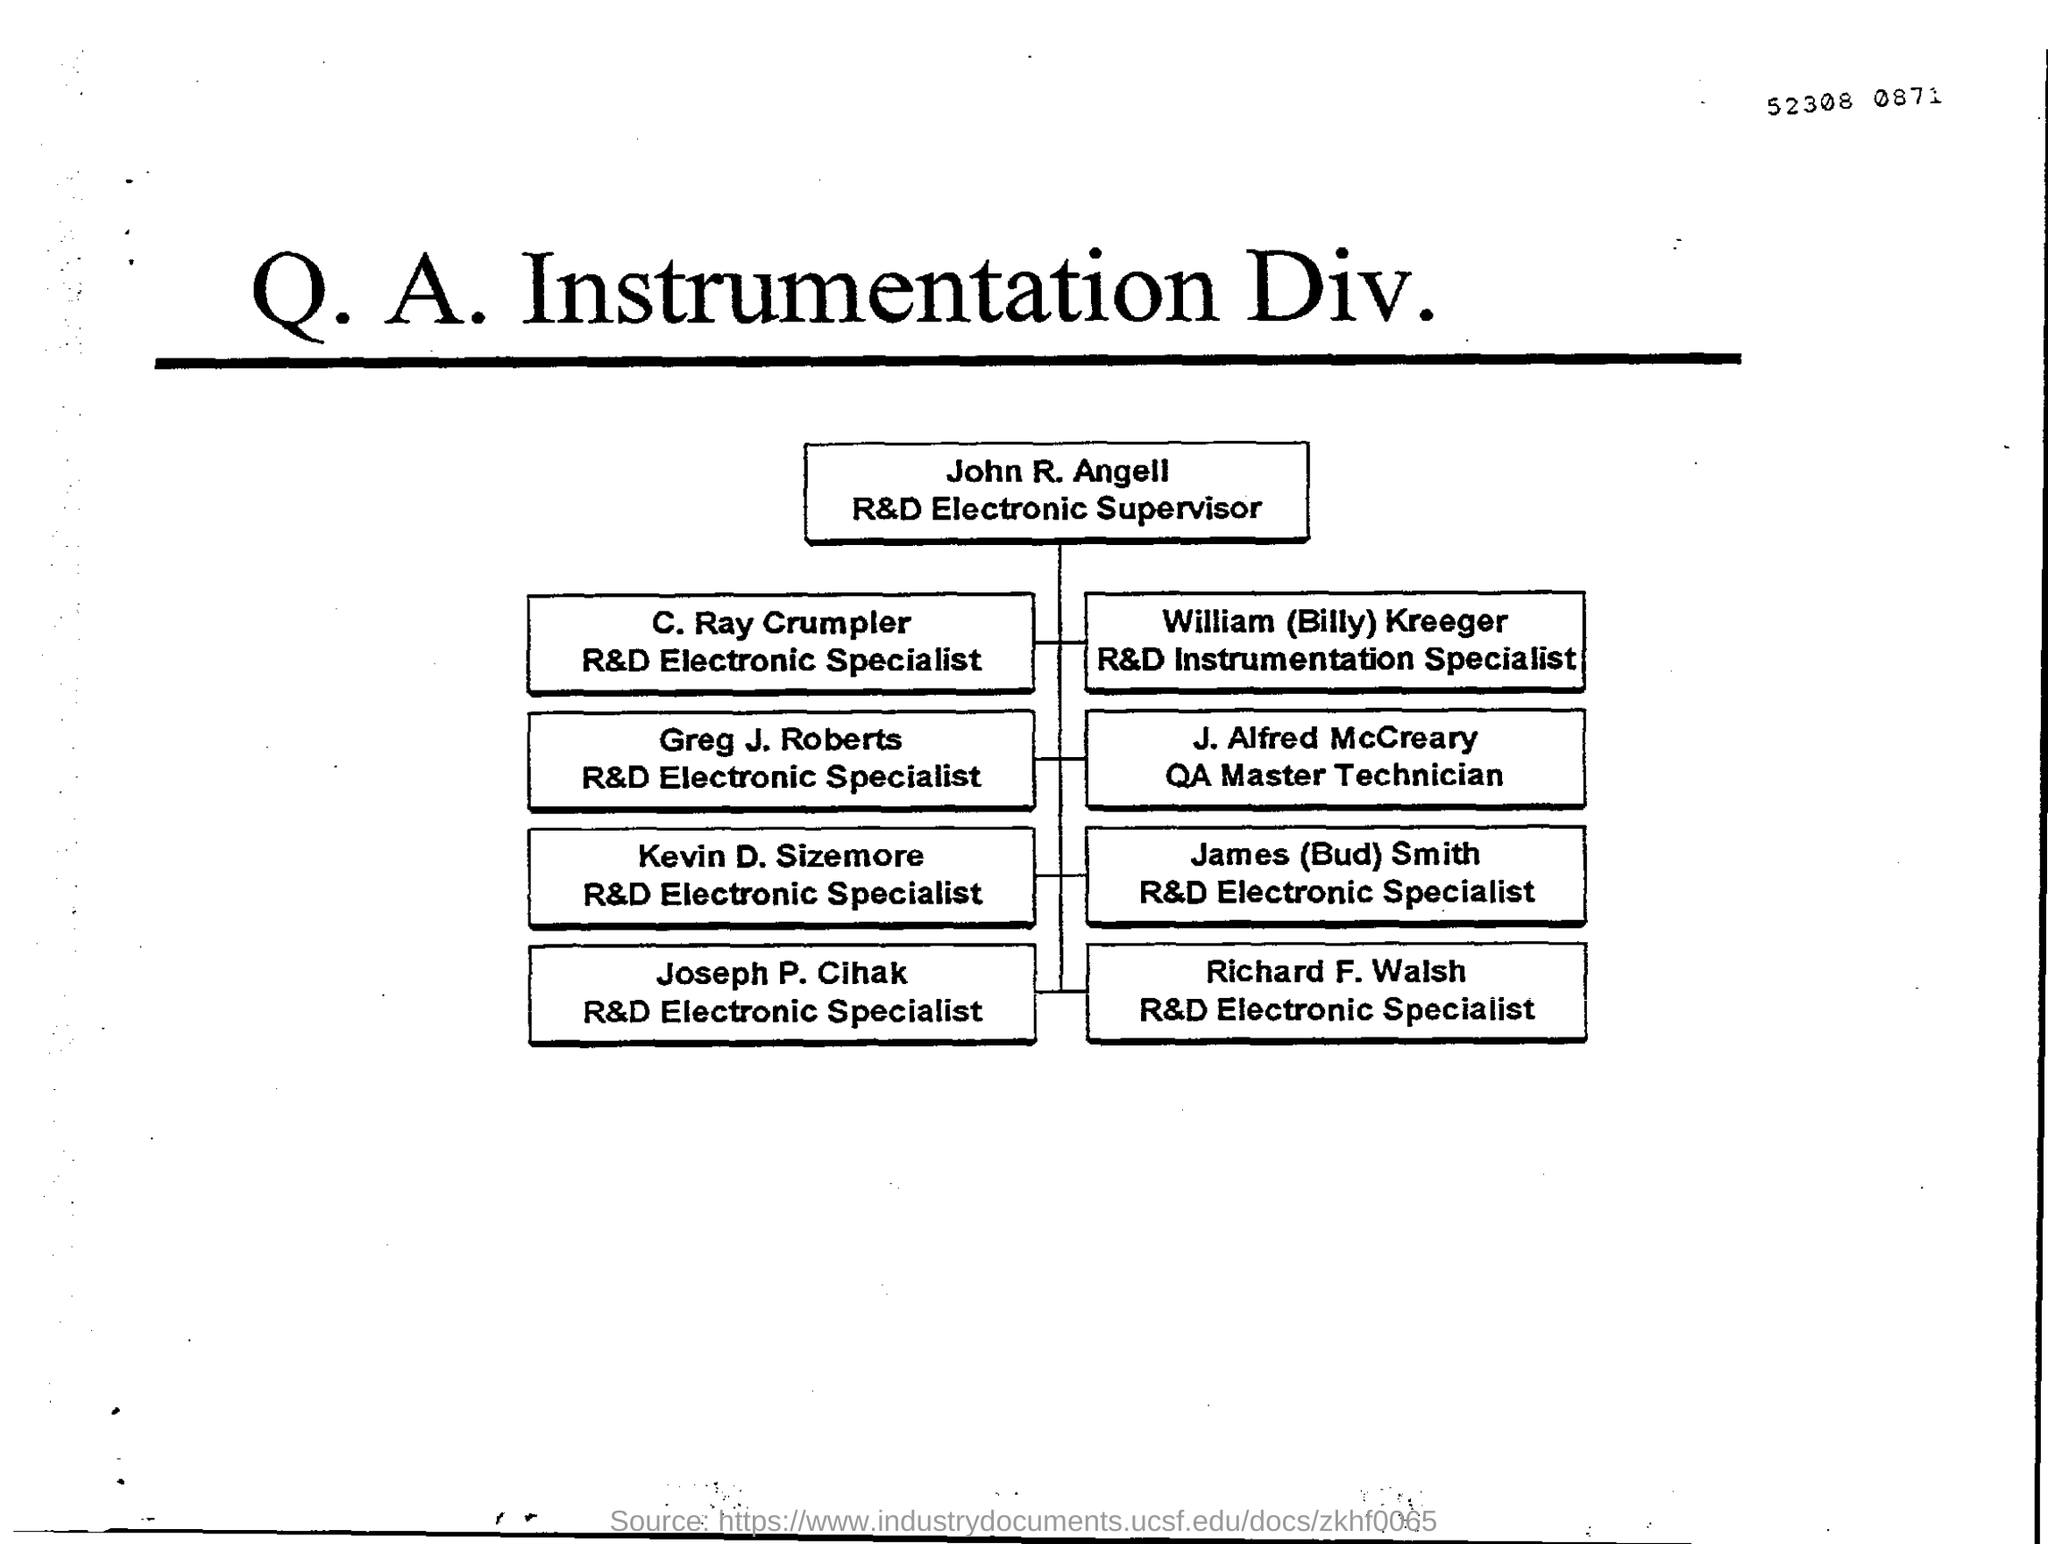Indicate a few pertinent items in this graphic. The name of the R&D Electronic Supervisor is John R. Angell. 